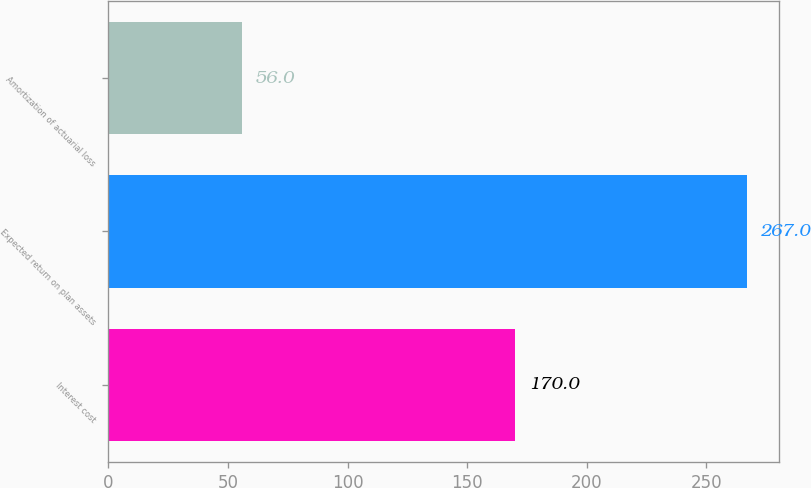Convert chart to OTSL. <chart><loc_0><loc_0><loc_500><loc_500><bar_chart><fcel>Interest cost<fcel>Expected return on plan assets<fcel>Amortization of actuarial loss<nl><fcel>170<fcel>267<fcel>56<nl></chart> 